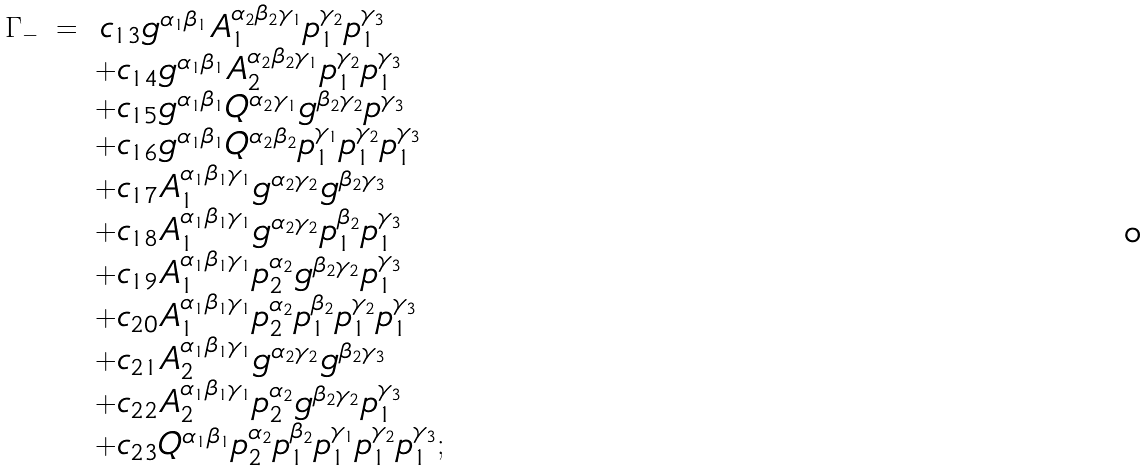<formula> <loc_0><loc_0><loc_500><loc_500>\begin{array} { r c l } \Gamma _ { - } & = & \, c _ { 1 3 } g ^ { \alpha _ { 1 } \beta _ { 1 } } A _ { 1 } ^ { \alpha _ { 2 } \beta _ { 2 } \gamma _ { 1 } } p _ { 1 } ^ { \gamma _ { 2 } } p _ { 1 } ^ { \gamma _ { 3 } } \\ & & + c _ { 1 4 } g ^ { \alpha _ { 1 } \beta _ { 1 } } A _ { 2 } ^ { \alpha _ { 2 } \beta _ { 2 } \gamma _ { 1 } } p _ { 1 } ^ { \gamma _ { 2 } } p _ { 1 } ^ { \gamma _ { 3 } } \\ & & + c _ { 1 5 } g ^ { \alpha _ { 1 } \beta _ { 1 } } Q ^ { \alpha _ { 2 } \gamma _ { 1 } } g ^ { \beta _ { 2 } \gamma _ { 2 } } p ^ { \gamma _ { 3 } } \\ & & + c _ { 1 6 } g ^ { \alpha _ { 1 } \beta _ { 1 } } Q ^ { \alpha _ { 2 } \beta _ { 2 } } p _ { 1 } ^ { \gamma _ { 1 } } p _ { 1 } ^ { \gamma _ { 2 } } p _ { 1 } ^ { \gamma _ { 3 } } \\ & & + c _ { 1 7 } A _ { 1 } ^ { \alpha _ { 1 } \beta _ { 1 } \gamma _ { 1 } } g ^ { \alpha _ { 2 } \gamma _ { 2 } } g ^ { \beta _ { 2 } \gamma _ { 3 } } \\ & & + c _ { 1 8 } A _ { 1 } ^ { \alpha _ { 1 } \beta _ { 1 } \gamma _ { 1 } } g ^ { \alpha _ { 2 } \gamma _ { 2 } } p _ { 1 } ^ { \beta _ { 2 } } p _ { 1 } ^ { \gamma _ { 3 } } \\ & & + c _ { 1 9 } A _ { 1 } ^ { \alpha _ { 1 } \beta _ { 1 } \gamma _ { 1 } } p _ { 2 } ^ { \alpha _ { 2 } } g ^ { \beta _ { 2 } \gamma _ { 2 } } p _ { 1 } ^ { \gamma _ { 3 } } \\ & & + c _ { 2 0 } A _ { 1 } ^ { \alpha _ { 1 } \beta _ { 1 } \gamma _ { 1 } } p _ { 2 } ^ { \alpha _ { 2 } } p _ { 1 } ^ { \beta _ { 2 } } p _ { 1 } ^ { \gamma _ { 2 } } p _ { 1 } ^ { \gamma _ { 3 } } \\ & & + c _ { 2 1 } A _ { 2 } ^ { \alpha _ { 1 } \beta _ { 1 } \gamma _ { 1 } } g ^ { \alpha _ { 2 } \gamma _ { 2 } } g ^ { \beta _ { 2 } \gamma _ { 3 } } \\ & & + c _ { 2 2 } A _ { 2 } ^ { \alpha _ { 1 } \beta _ { 1 } \gamma _ { 1 } } p _ { 2 } ^ { \alpha _ { 2 } } g ^ { \beta _ { 2 } \gamma _ { 2 } } p _ { 1 } ^ { \gamma _ { 3 } } \\ & & + c _ { 2 3 } Q ^ { \alpha _ { 1 } \beta _ { 1 } } p _ { 2 } ^ { \alpha _ { 2 } } p _ { 1 } ^ { \beta _ { 2 } } p _ { 1 } ^ { \gamma _ { 1 } } p _ { 1 } ^ { \gamma _ { 2 } } p _ { 1 } ^ { \gamma _ { 3 } } ; \end{array}</formula> 